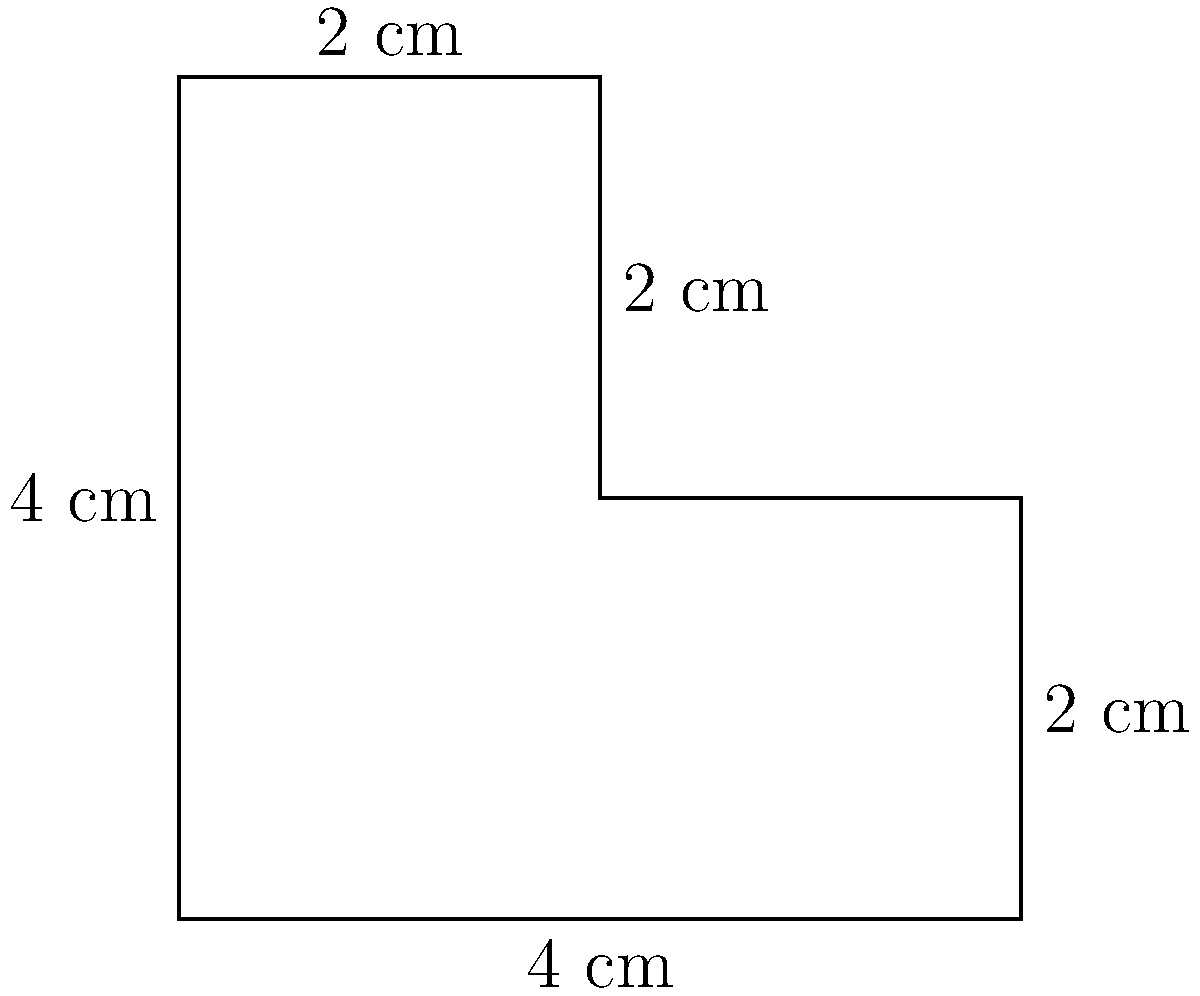As an art student, you've been given an irregularly shaped canvas for a unique project. The canvas is formed by cutting out a 2 cm × 2 cm square from a 4 cm × 4 cm square, as shown in the diagram. Calculate the area of this canvas in square centimeters. To find the area of this irregularly shaped canvas, we can follow these steps:

1. Identify the shape: The canvas is a 4 cm × 4 cm square with a 2 cm × 2 cm square cut out from its top-right corner.

2. Calculate the area of the larger square:
   Area of larger square = $4 \text{ cm} \times 4 \text{ cm} = 16 \text{ cm}^2$

3. Calculate the area of the smaller square (the cut-out portion):
   Area of smaller square = $2 \text{ cm} \times 2 \text{ cm} = 4 \text{ cm}^2$

4. Subtract the area of the smaller square from the area of the larger square:
   Area of canvas = Area of larger square - Area of smaller square
   $$\text{Area of canvas} = 16 \text{ cm}^2 - 4 \text{ cm}^2 = 12 \text{ cm}^2$$

Therefore, the area of the irregularly shaped canvas is 12 square centimeters.
Answer: $12 \text{ cm}^2$ 